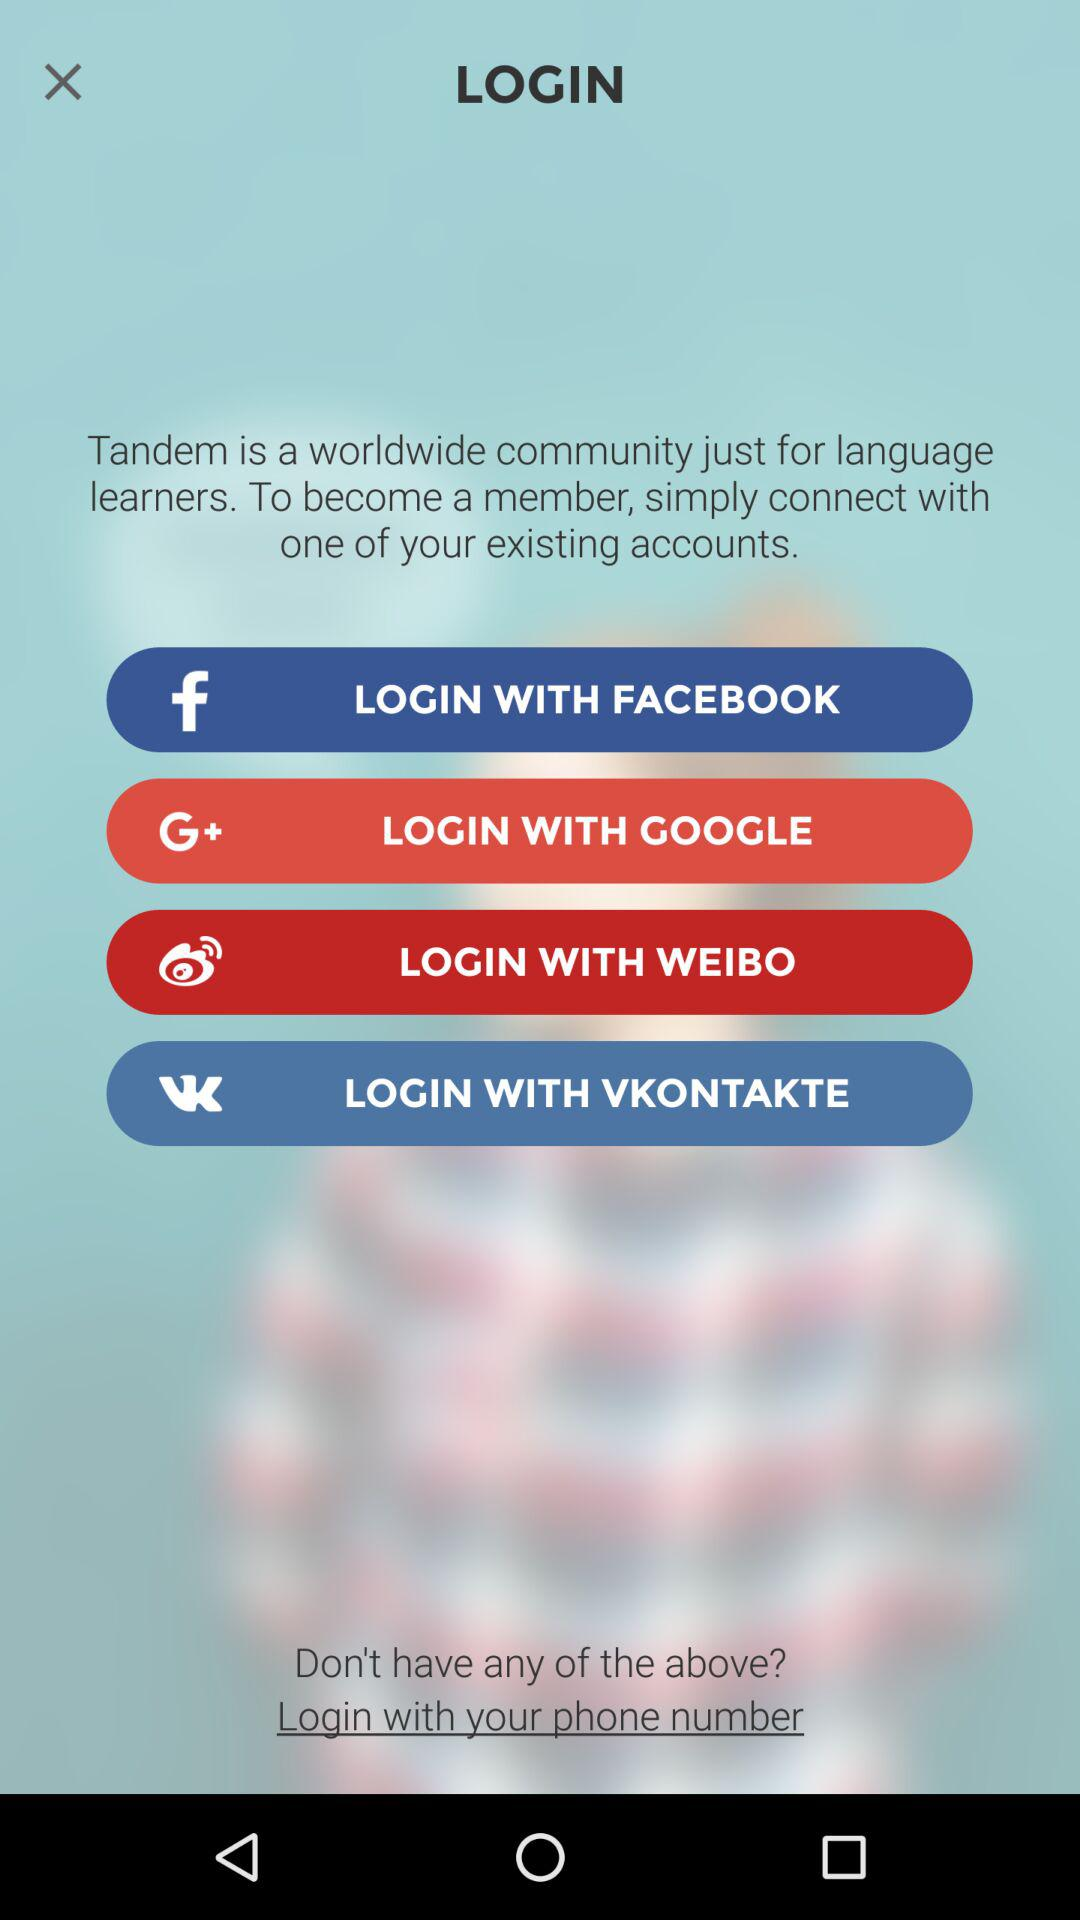What applications are used for login? The applications are "FACEBOOK", "GOOGLE", "WEIBO" and "VKONTAKTE". 